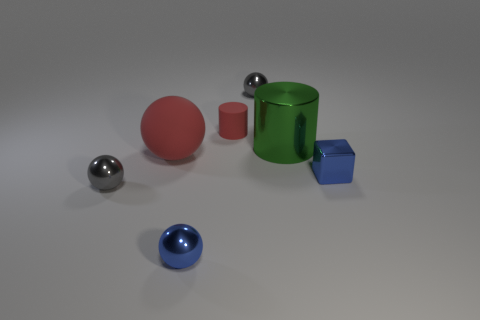There is a tiny shiny thing that is in front of the large rubber object and on the right side of the rubber cylinder; what color is it?
Your answer should be very brief. Blue. The object that is the same color as the small shiny cube is what size?
Give a very brief answer. Small. What material is the tiny blue thing that is behind the small gray metal thing in front of the red sphere?
Provide a succinct answer. Metal. What number of tiny spheres are behind the cylinder on the right side of the gray shiny thing that is behind the big green object?
Offer a terse response. 1. Is the material of the tiny ball that is on the right side of the red matte cylinder the same as the blue object to the right of the small cylinder?
Ensure brevity in your answer.  Yes. What is the material of the large thing that is the same color as the small rubber cylinder?
Your answer should be compact. Rubber. What number of other things have the same shape as the big red thing?
Offer a terse response. 3. Are there more large red balls behind the big red sphere than green things?
Offer a terse response. No. The small gray metal thing left of the tiny gray metallic sphere that is behind the small object left of the small blue metallic sphere is what shape?
Your answer should be compact. Sphere. There is a tiny gray object that is to the right of the tiny red cylinder; is it the same shape as the small blue metal object that is left of the large metallic thing?
Provide a short and direct response. Yes. 